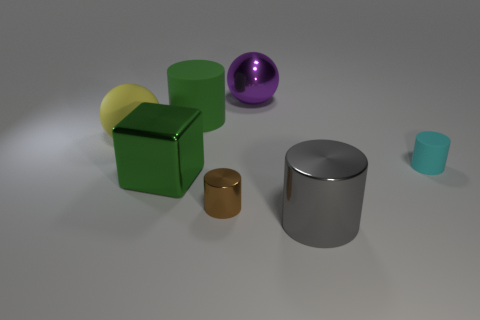Add 1 green blocks. How many objects exist? 8 Subtract all gray cylinders. How many cylinders are left? 3 Subtract 3 cylinders. How many cylinders are left? 1 Subtract all green cylinders. How many cylinders are left? 3 Subtract all balls. How many objects are left? 5 Subtract 1 yellow balls. How many objects are left? 6 Subtract all yellow cylinders. Subtract all purple cubes. How many cylinders are left? 4 Subtract all small green shiny balls. Subtract all cyan matte cylinders. How many objects are left? 6 Add 1 large rubber things. How many large rubber things are left? 3 Add 1 big green objects. How many big green objects exist? 3 